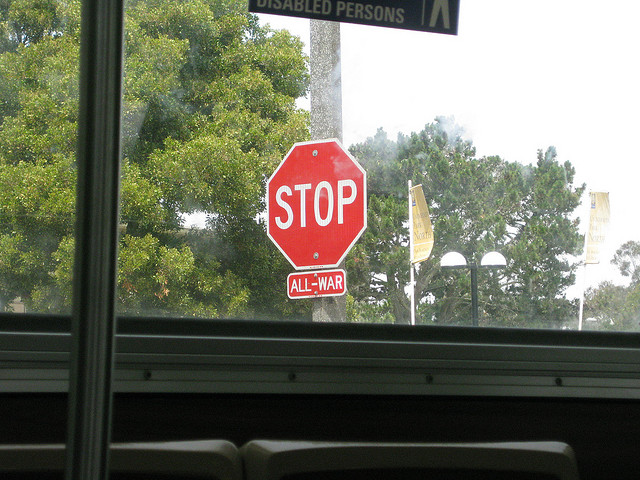Read all the text in this image. STOP ALL WAR DISABLED PERSONS 